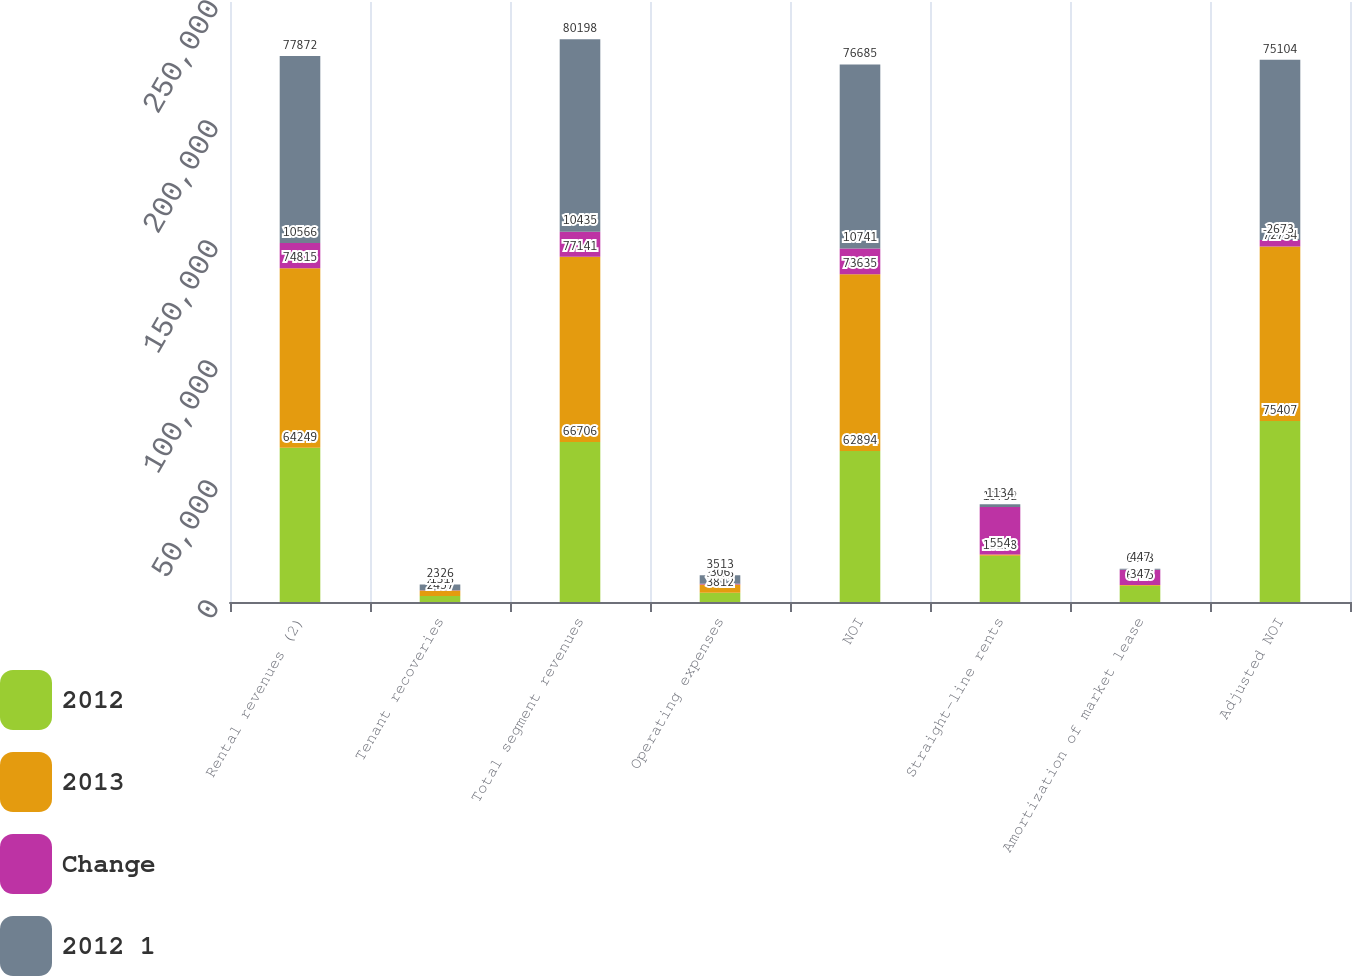Convert chart to OTSL. <chart><loc_0><loc_0><loc_500><loc_500><stacked_bar_chart><ecel><fcel>Rental revenues (2)<fcel>Tenant recoveries<fcel>Total segment revenues<fcel>Operating expenses<fcel>NOI<fcel>Straight-line rents<fcel>Amortization of market lease<fcel>Adjusted NOI<nl><fcel>2012<fcel>64249<fcel>2457<fcel>66706<fcel>3812<fcel>62894<fcel>19238<fcel>6725<fcel>75407<nl><fcel>2013<fcel>74815<fcel>2326<fcel>77141<fcel>3506<fcel>73635<fcel>554<fcel>347<fcel>72734<nl><fcel>Change<fcel>10566<fcel>131<fcel>10435<fcel>306<fcel>10741<fcel>19792<fcel>6378<fcel>2673<nl><fcel>2012 1<fcel>77872<fcel>2326<fcel>80198<fcel>3513<fcel>76685<fcel>1134<fcel>447<fcel>75104<nl></chart> 